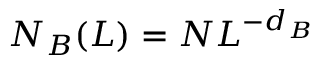<formula> <loc_0><loc_0><loc_500><loc_500>N _ { B } ( L ) = N L ^ { - d _ { B } }</formula> 